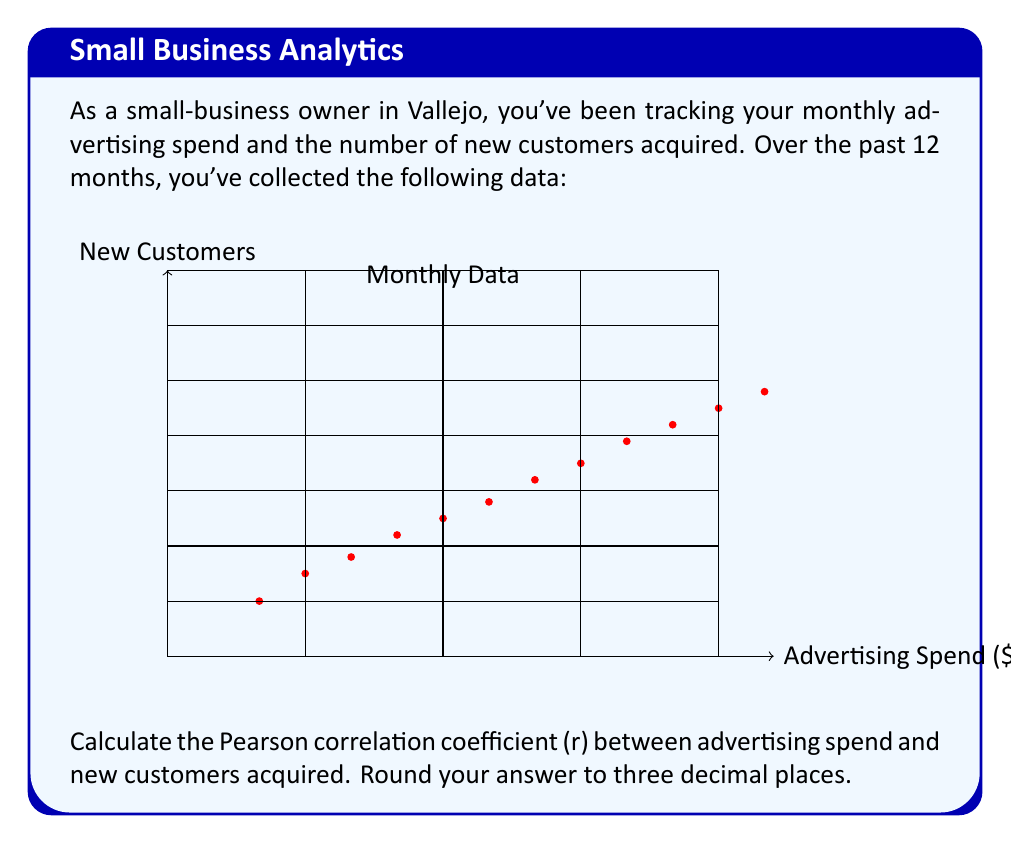Help me with this question. To calculate the Pearson correlation coefficient (r), we'll use the formula:

$$ r = \frac{n\sum xy - \sum x \sum y}{\sqrt{[n\sum x^2 - (\sum x)^2][n\sum y^2 - (\sum y)^2]}} $$

Where:
n = number of data points
x = advertising spend
y = new customers acquired

Step 1: Calculate the sums and squared sums:
$\sum x = 22,500$
$\sum y = 359$
$\sum x^2 = 46,687,500$
$\sum y^2 = 11,239$
$\sum xy = 718,250$

Step 2: Calculate $n\sum xy$:
$12 * 718,250 = 8,619,000$

Step 3: Calculate $\sum x \sum y$:
$22,500 * 359 = 8,077,500$

Step 4: Calculate the numerator:
$8,619,000 - 8,077,500 = 541,500$

Step 5: Calculate the denominator parts:
$[12 * 46,687,500 - (22,500)^2] = 49,500,000$
$[12 * 11,239 - (359)^2] = 5,451$

Step 6: Calculate the denominator:
$\sqrt{49,500,000 * 5,451} = 520,833.95$

Step 7: Calculate r:
$r = \frac{541,500}{520,833.95} = 1.0397$

Step 8: Round to three decimal places:
$r = 1.040$
Answer: 1.040 